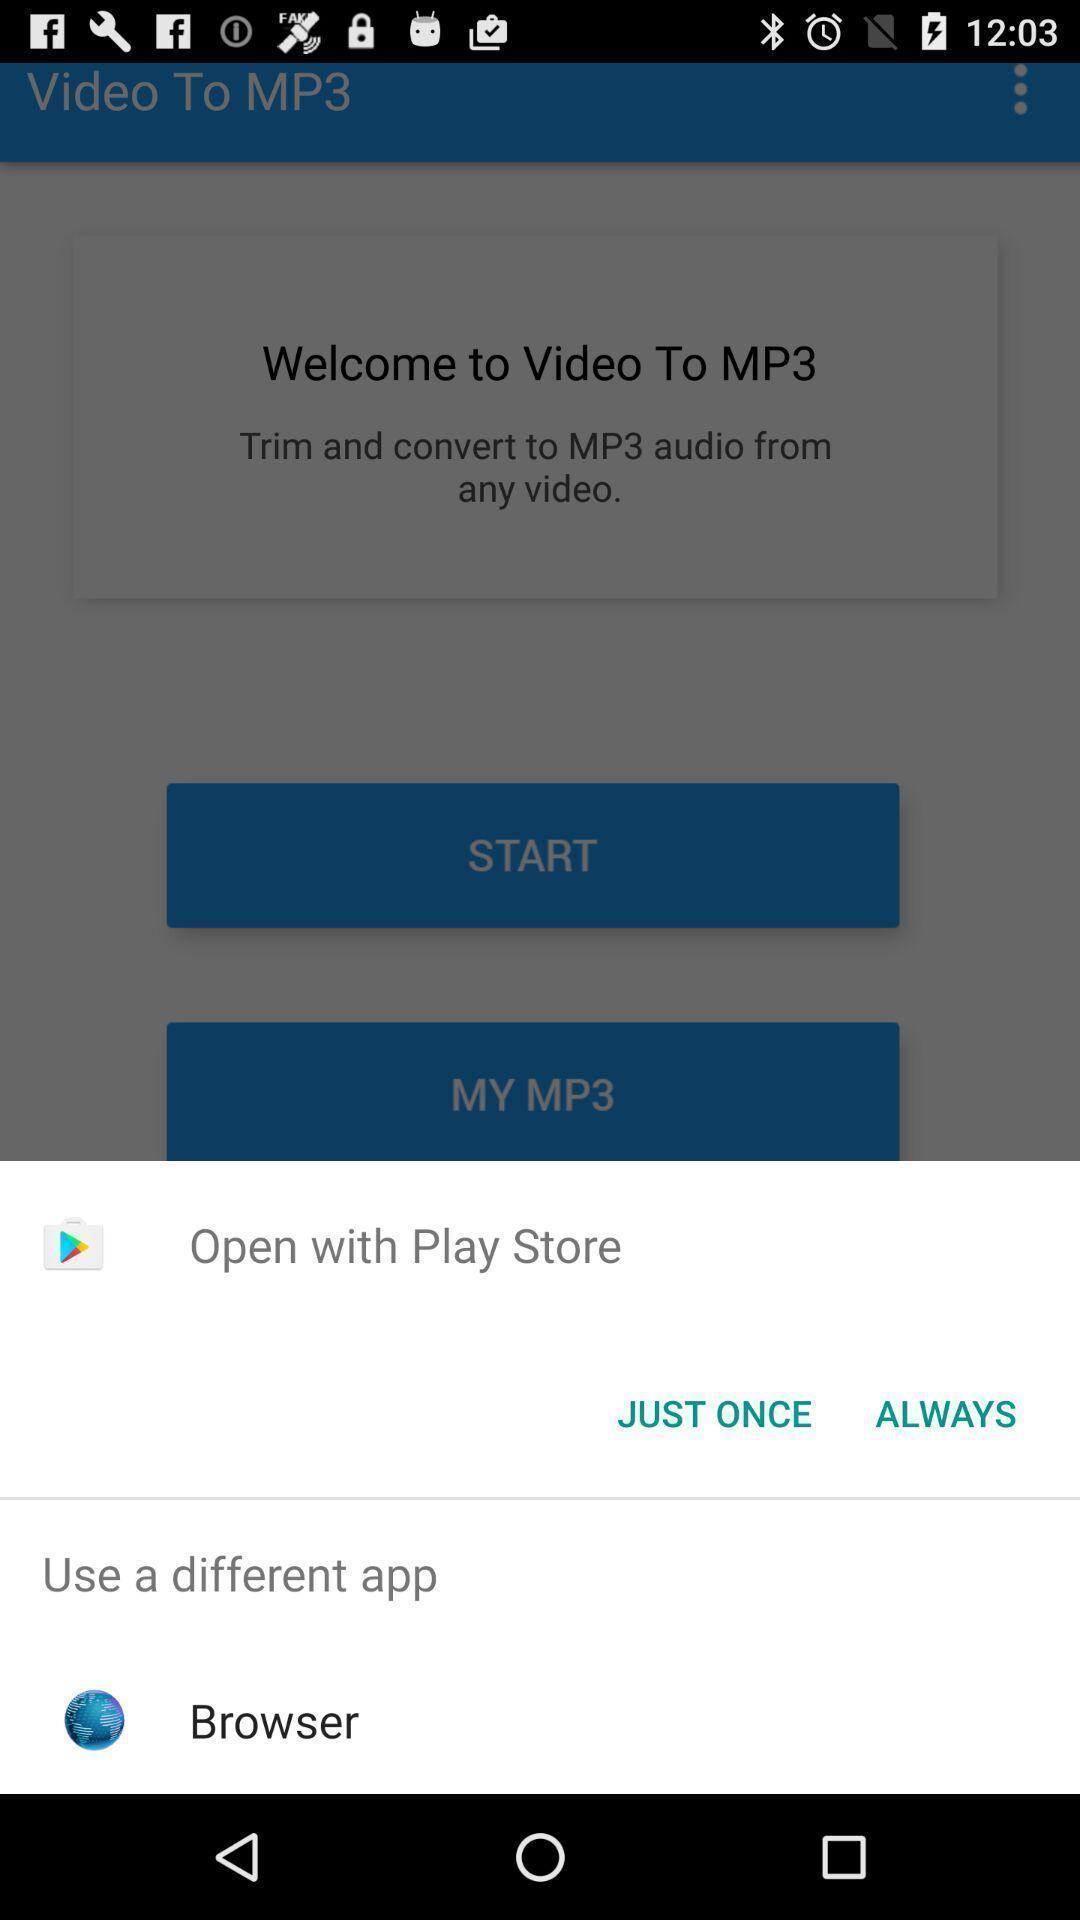Provide a textual representation of this image. Pop-up displaying different applications to open. 